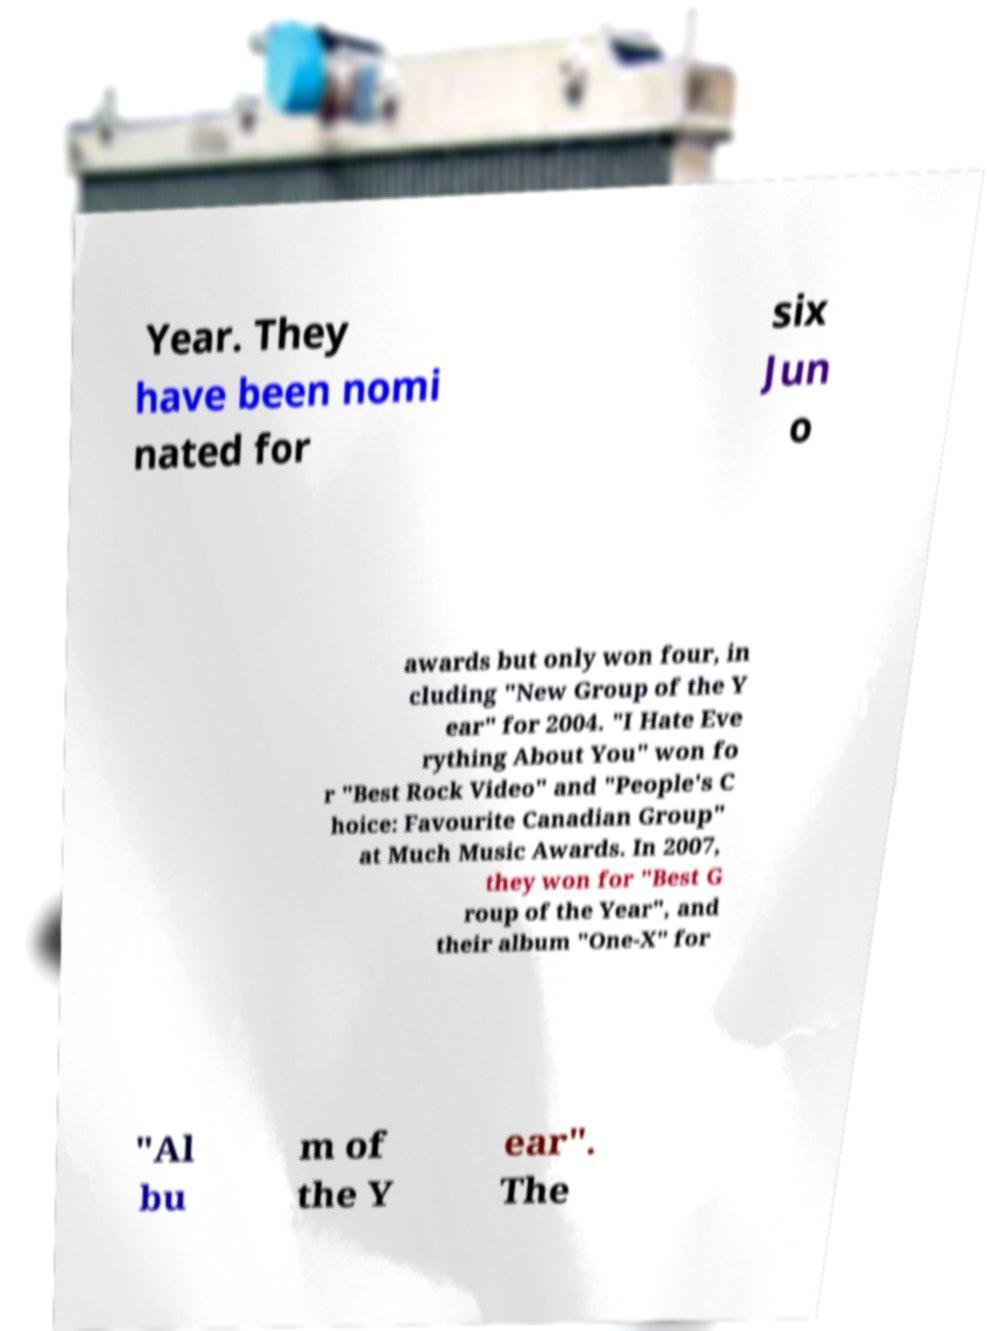Please identify and transcribe the text found in this image. Year. They have been nomi nated for six Jun o awards but only won four, in cluding "New Group of the Y ear" for 2004. "I Hate Eve rything About You" won fo r "Best Rock Video" and "People's C hoice: Favourite Canadian Group" at Much Music Awards. In 2007, they won for "Best G roup of the Year", and their album "One-X" for "Al bu m of the Y ear". The 